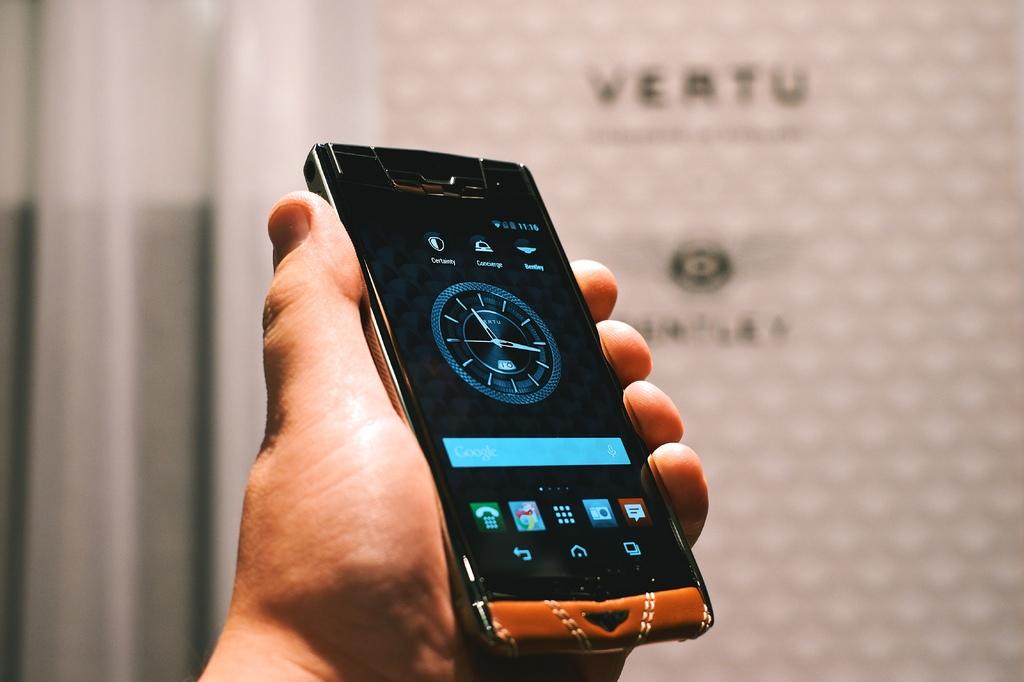What time is it?
Keep it short and to the point. 11:16. 